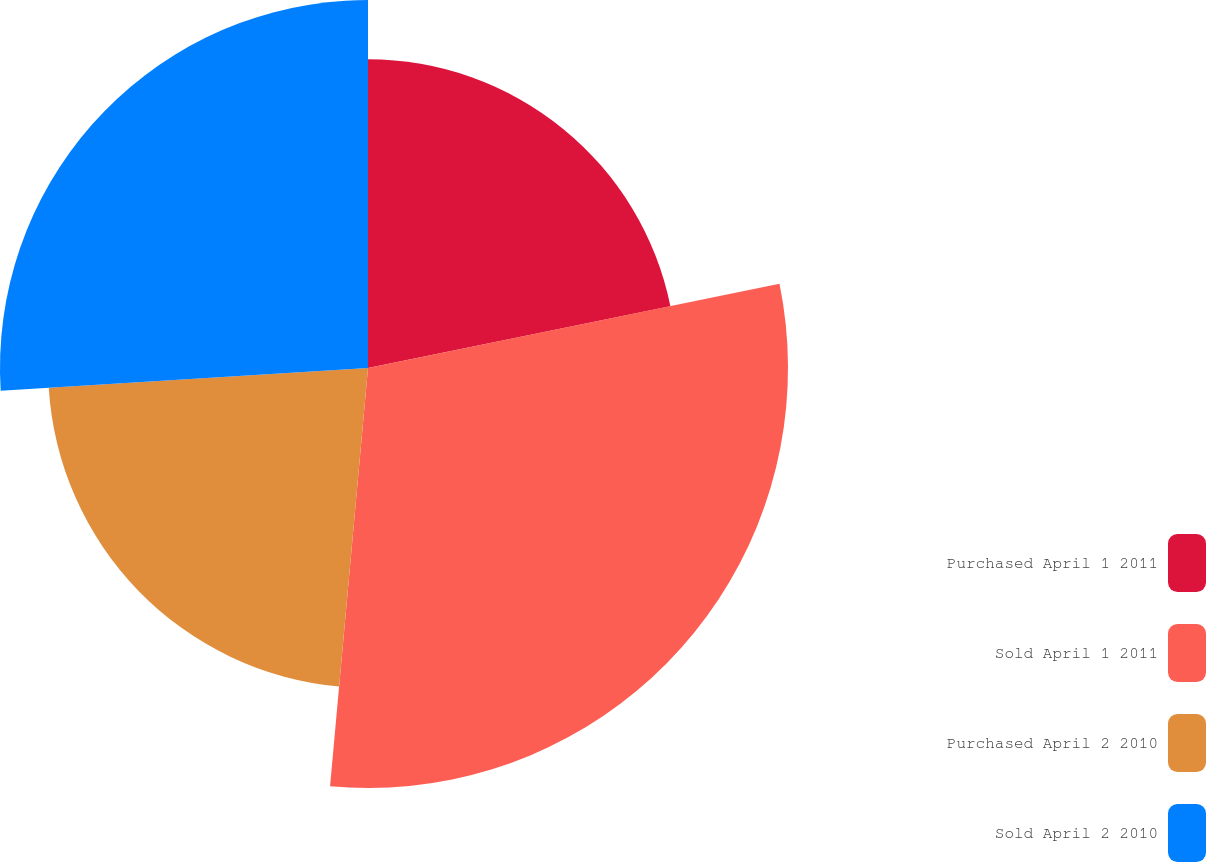<chart> <loc_0><loc_0><loc_500><loc_500><pie_chart><fcel>Purchased April 1 2011<fcel>Sold April 1 2011<fcel>Purchased April 2 2010<fcel>Sold April 2 2010<nl><fcel>21.79%<fcel>29.65%<fcel>22.58%<fcel>25.98%<nl></chart> 